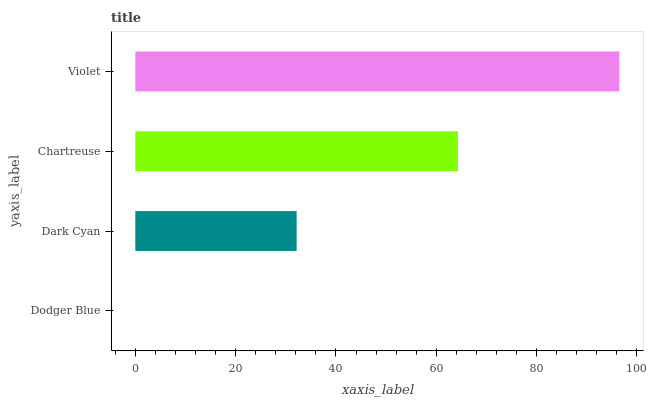Is Dodger Blue the minimum?
Answer yes or no. Yes. Is Violet the maximum?
Answer yes or no. Yes. Is Dark Cyan the minimum?
Answer yes or no. No. Is Dark Cyan the maximum?
Answer yes or no. No. Is Dark Cyan greater than Dodger Blue?
Answer yes or no. Yes. Is Dodger Blue less than Dark Cyan?
Answer yes or no. Yes. Is Dodger Blue greater than Dark Cyan?
Answer yes or no. No. Is Dark Cyan less than Dodger Blue?
Answer yes or no. No. Is Chartreuse the high median?
Answer yes or no. Yes. Is Dark Cyan the low median?
Answer yes or no. Yes. Is Violet the high median?
Answer yes or no. No. Is Dodger Blue the low median?
Answer yes or no. No. 